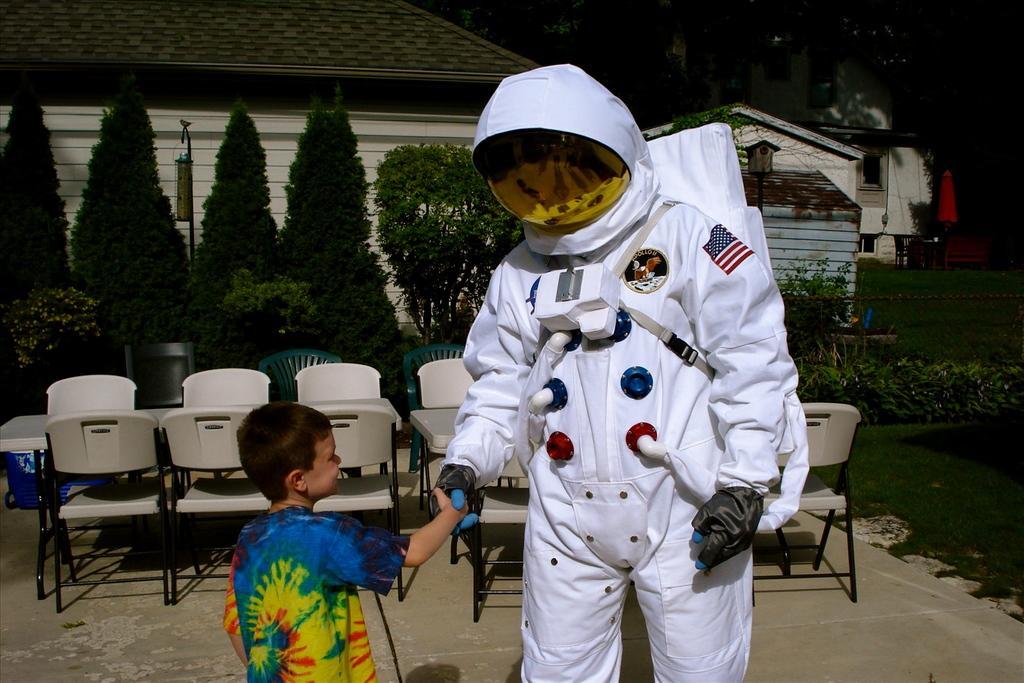In one or two sentences, can you explain what this image depicts? In this picture we can see person wore space costume with gloves to his hand and giving shake hand to the boy and in background we can see table, chairs, trees, house, grass. 